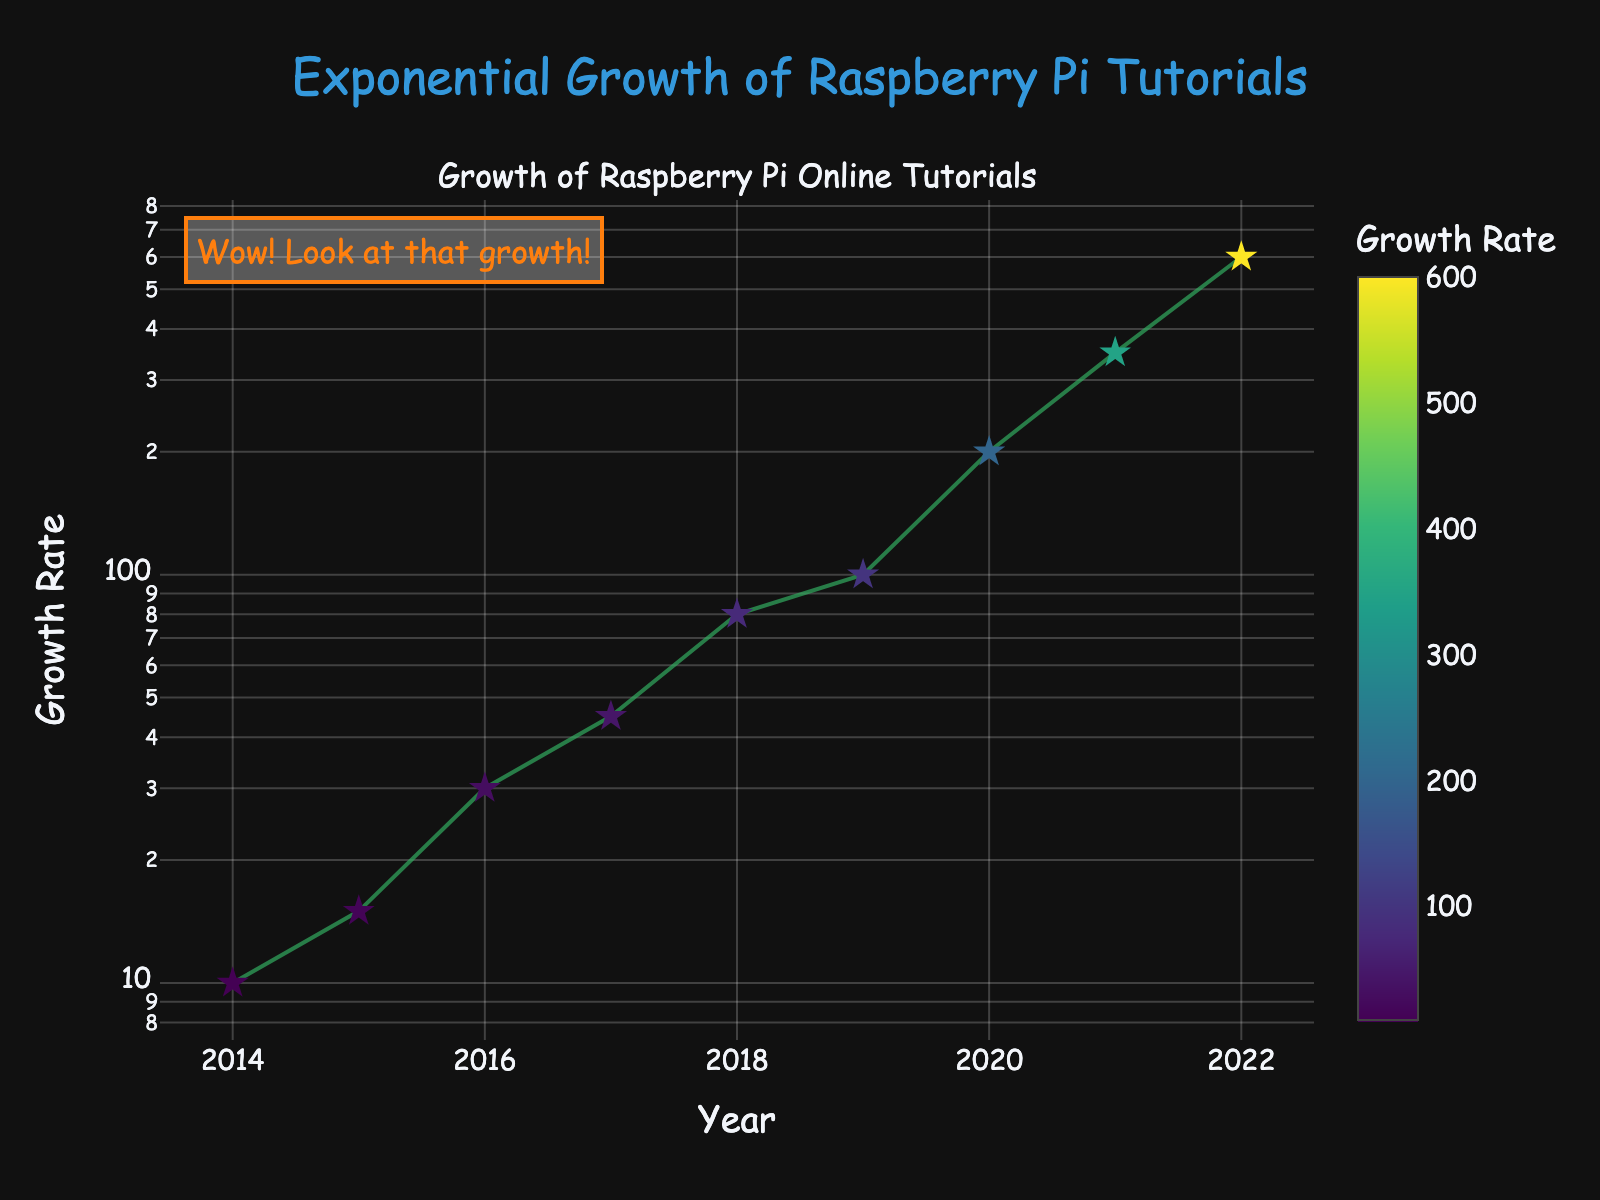How many data points are plotted in the figure? The figure shows each year from 2014 to 2022, which is a total of 9 years, so there are 9 data points represented.
Answer: 9 What is the color of the data point with the highest growth rate? The highest growth rate is 600 in the year 2022. The color for this data point from the Viridis colorscale is a bright yellow.
Answer: Yellow What type of line connects the data points? The data points are connected with lines that are greenish in color and semi-transparent.
Answer: Greenish lines In what year did the growth rate first exceed 100? The year when the growth rate first exceeded 100 is 2019, with a growth rate of 200.
Answer: 2019 What is the shape of the markers representing the growth rate on the plot? The markers representing the growth rates are in the shape of stars, as visually indicated by their appearance.
Answer: Star How many years show a growth rate greater than 350? From the figure, the years that show a growth rate greater than 350 are 2021 and 2022. That's 2 years in total.
Answer: 2 By how much did the growth rate increase from 2018 to 2019? The growth rate in 2018 was 80, and in 2019 it was 100. The difference is 100 - 80 = 20.
Answer: 20 How much faster did the growth rate increase from 2016 to 2017 compared to the increase from 2015 to 2016? The growth rate increase from 2015 to 2016 was 30 - 15 = 15, and from 2016 to 2017 it was 45 - 30 = 15. The increase in both periods is the same.
Answer: Same What does the annotation in the top left corner of the plot say, and what is its color? The annotation in the top left corner says, "Wow! Look at that growth!" and it is displayed in orange text.
Answer: “Wow! Look at that growth!”, Orange What type of scale is used for the y-axis, and why might it be used in this plot? The y-axis uses a logarithmic (log) scale. This type of scale is often used to better display data with a wide range of values, showing proportional increases more clearly.
Answer: Logarithmic scale 